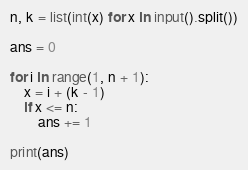Convert code to text. <code><loc_0><loc_0><loc_500><loc_500><_Python_>n, k = list(int(x) for x in input().split())

ans = 0

for i in range(1, n + 1):
    x = i + (k - 1)
    if x <= n:
        ans += 1

print(ans)</code> 